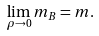Convert formula to latex. <formula><loc_0><loc_0><loc_500><loc_500>\lim _ { \rho \rightarrow 0 } m _ { B } = m .</formula> 